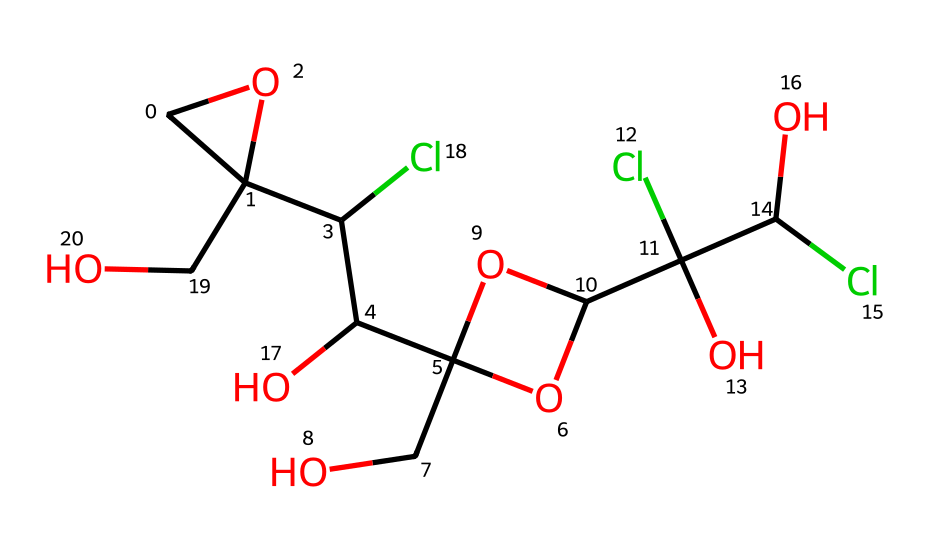What is the molecular formula of sucralose? The molecular formula can be determined by counting the number of each type of atom in the SMILES representation. In the given SMILES, there are 12 carbon (C) atoms, 19 hydrogen (H) atoms, 7 oxygen (O) atoms, and 3 chlorine (Cl) atoms. Thus, the molecular formula is C12H19Cl3O8.
Answer: C12H19Cl3O8 How many chlorine atoms are present in the structure? By analyzing the SMILES, we see that the "Cl" symbol appears three times, indicating the presence of three chlorine atoms in the structure.
Answer: 3 What type of functional groups are present in sucralose? Evaluating the structure from the SMILES, the presence of -OH groups (hydroxyl) and -Cl (chlorine) substituents indicates that both hydroxyl and halogen functional groups are present.
Answer: hydroxyl and halogen What role do chlorine atoms play in sucralose's sweetness? The chlorine atoms in sucralose contribute to its stability and sweetness by modifying the molecular interactions that occur with taste receptors on the tongue, enhancing its sweet flavor compared to sugar.
Answer: sweetness enhancement How many rings are present in the structure of sucralose? The structure has two distinct ring structures as indicated by the 'C1' and 'C2' labels in the SMILES, which signify the start of cyclic compounds.
Answer: 2 Which part of the structure contributes most to its low caloric value? The presence of chlorine substituents at specific positions prevents sucralose from being metabolized as energy, thereby contributing to its low caloric value.
Answer: chlorine substituents 